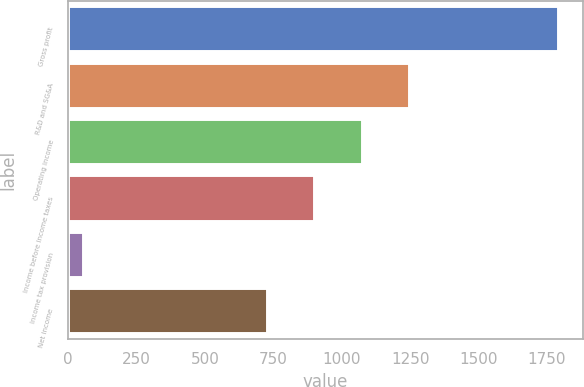Convert chart. <chart><loc_0><loc_0><loc_500><loc_500><bar_chart><fcel>Gross profit<fcel>R&D and SG&A<fcel>Operating income<fcel>Income before income taxes<fcel>Income tax provision<fcel>Net income<nl><fcel>1791<fcel>1247.1<fcel>1073.4<fcel>899.7<fcel>54<fcel>726<nl></chart> 